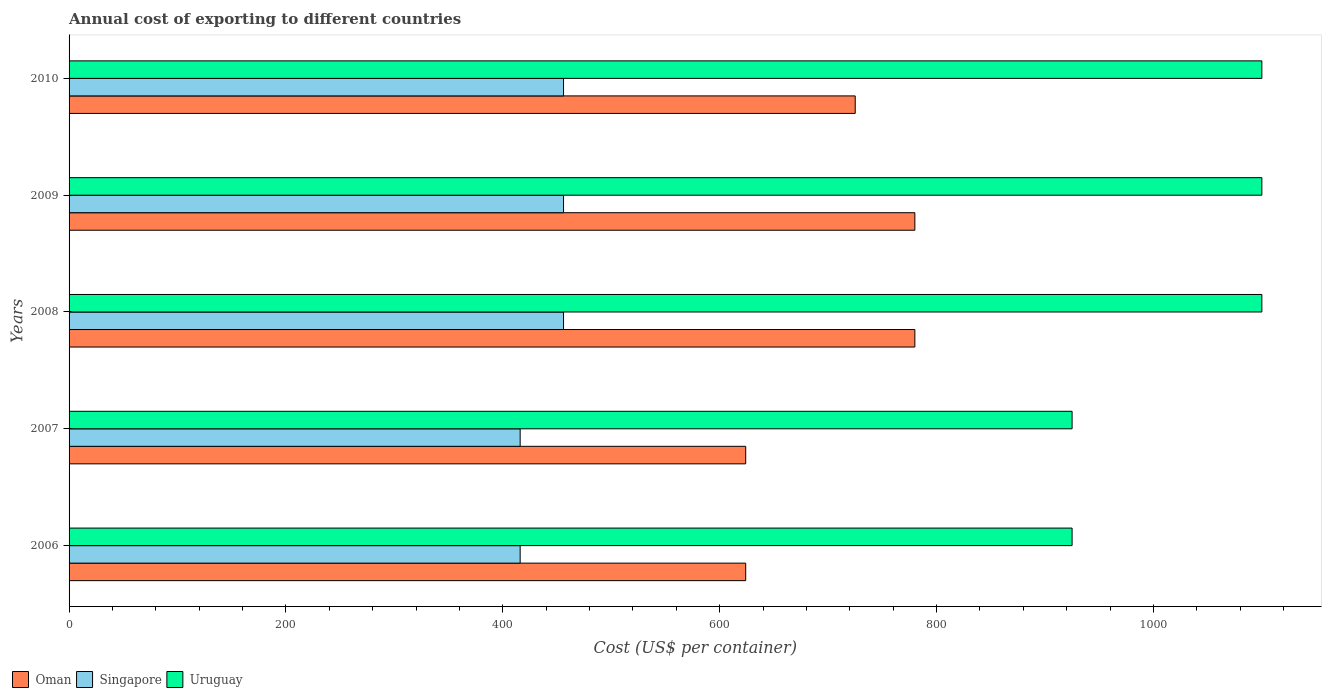How many groups of bars are there?
Your response must be concise. 5. Are the number of bars per tick equal to the number of legend labels?
Offer a very short reply. Yes. What is the total annual cost of exporting in Uruguay in 2007?
Your answer should be very brief. 925. Across all years, what is the maximum total annual cost of exporting in Uruguay?
Make the answer very short. 1100. Across all years, what is the minimum total annual cost of exporting in Singapore?
Offer a very short reply. 416. In which year was the total annual cost of exporting in Oman maximum?
Ensure brevity in your answer.  2008. In which year was the total annual cost of exporting in Singapore minimum?
Offer a terse response. 2006. What is the total total annual cost of exporting in Oman in the graph?
Ensure brevity in your answer.  3533. What is the difference between the total annual cost of exporting in Singapore in 2007 and that in 2008?
Make the answer very short. -40. What is the difference between the total annual cost of exporting in Oman in 2009 and the total annual cost of exporting in Singapore in 2007?
Provide a short and direct response. 364. What is the average total annual cost of exporting in Singapore per year?
Make the answer very short. 440. In the year 2009, what is the difference between the total annual cost of exporting in Uruguay and total annual cost of exporting in Singapore?
Keep it short and to the point. 644. In how many years, is the total annual cost of exporting in Oman greater than 440 US$?
Keep it short and to the point. 5. What is the difference between the highest and the lowest total annual cost of exporting in Oman?
Provide a succinct answer. 156. In how many years, is the total annual cost of exporting in Oman greater than the average total annual cost of exporting in Oman taken over all years?
Give a very brief answer. 3. Is the sum of the total annual cost of exporting in Oman in 2007 and 2010 greater than the maximum total annual cost of exporting in Singapore across all years?
Offer a very short reply. Yes. What does the 3rd bar from the top in 2010 represents?
Offer a very short reply. Oman. What does the 3rd bar from the bottom in 2006 represents?
Ensure brevity in your answer.  Uruguay. Are all the bars in the graph horizontal?
Provide a short and direct response. Yes. How many years are there in the graph?
Your answer should be compact. 5. Are the values on the major ticks of X-axis written in scientific E-notation?
Offer a terse response. No. Does the graph contain grids?
Give a very brief answer. No. How many legend labels are there?
Your response must be concise. 3. How are the legend labels stacked?
Offer a very short reply. Horizontal. What is the title of the graph?
Your answer should be very brief. Annual cost of exporting to different countries. What is the label or title of the X-axis?
Make the answer very short. Cost (US$ per container). What is the label or title of the Y-axis?
Give a very brief answer. Years. What is the Cost (US$ per container) of Oman in 2006?
Keep it short and to the point. 624. What is the Cost (US$ per container) of Singapore in 2006?
Your response must be concise. 416. What is the Cost (US$ per container) in Uruguay in 2006?
Keep it short and to the point. 925. What is the Cost (US$ per container) of Oman in 2007?
Keep it short and to the point. 624. What is the Cost (US$ per container) of Singapore in 2007?
Provide a succinct answer. 416. What is the Cost (US$ per container) in Uruguay in 2007?
Provide a short and direct response. 925. What is the Cost (US$ per container) in Oman in 2008?
Your answer should be compact. 780. What is the Cost (US$ per container) of Singapore in 2008?
Provide a short and direct response. 456. What is the Cost (US$ per container) of Uruguay in 2008?
Offer a terse response. 1100. What is the Cost (US$ per container) of Oman in 2009?
Offer a terse response. 780. What is the Cost (US$ per container) of Singapore in 2009?
Give a very brief answer. 456. What is the Cost (US$ per container) in Uruguay in 2009?
Ensure brevity in your answer.  1100. What is the Cost (US$ per container) in Oman in 2010?
Offer a terse response. 725. What is the Cost (US$ per container) in Singapore in 2010?
Provide a short and direct response. 456. What is the Cost (US$ per container) in Uruguay in 2010?
Offer a very short reply. 1100. Across all years, what is the maximum Cost (US$ per container) in Oman?
Offer a terse response. 780. Across all years, what is the maximum Cost (US$ per container) in Singapore?
Offer a terse response. 456. Across all years, what is the maximum Cost (US$ per container) of Uruguay?
Offer a very short reply. 1100. Across all years, what is the minimum Cost (US$ per container) of Oman?
Give a very brief answer. 624. Across all years, what is the minimum Cost (US$ per container) in Singapore?
Your answer should be very brief. 416. Across all years, what is the minimum Cost (US$ per container) in Uruguay?
Make the answer very short. 925. What is the total Cost (US$ per container) of Oman in the graph?
Provide a short and direct response. 3533. What is the total Cost (US$ per container) in Singapore in the graph?
Your response must be concise. 2200. What is the total Cost (US$ per container) of Uruguay in the graph?
Give a very brief answer. 5150. What is the difference between the Cost (US$ per container) in Oman in 2006 and that in 2007?
Provide a succinct answer. 0. What is the difference between the Cost (US$ per container) in Uruguay in 2006 and that in 2007?
Give a very brief answer. 0. What is the difference between the Cost (US$ per container) in Oman in 2006 and that in 2008?
Your answer should be compact. -156. What is the difference between the Cost (US$ per container) of Uruguay in 2006 and that in 2008?
Give a very brief answer. -175. What is the difference between the Cost (US$ per container) in Oman in 2006 and that in 2009?
Ensure brevity in your answer.  -156. What is the difference between the Cost (US$ per container) of Uruguay in 2006 and that in 2009?
Your response must be concise. -175. What is the difference between the Cost (US$ per container) of Oman in 2006 and that in 2010?
Keep it short and to the point. -101. What is the difference between the Cost (US$ per container) of Singapore in 2006 and that in 2010?
Ensure brevity in your answer.  -40. What is the difference between the Cost (US$ per container) of Uruguay in 2006 and that in 2010?
Ensure brevity in your answer.  -175. What is the difference between the Cost (US$ per container) in Oman in 2007 and that in 2008?
Your answer should be very brief. -156. What is the difference between the Cost (US$ per container) of Singapore in 2007 and that in 2008?
Your response must be concise. -40. What is the difference between the Cost (US$ per container) in Uruguay in 2007 and that in 2008?
Your answer should be very brief. -175. What is the difference between the Cost (US$ per container) of Oman in 2007 and that in 2009?
Offer a very short reply. -156. What is the difference between the Cost (US$ per container) in Singapore in 2007 and that in 2009?
Your answer should be compact. -40. What is the difference between the Cost (US$ per container) of Uruguay in 2007 and that in 2009?
Provide a short and direct response. -175. What is the difference between the Cost (US$ per container) of Oman in 2007 and that in 2010?
Your answer should be very brief. -101. What is the difference between the Cost (US$ per container) in Uruguay in 2007 and that in 2010?
Your response must be concise. -175. What is the difference between the Cost (US$ per container) in Singapore in 2008 and that in 2009?
Give a very brief answer. 0. What is the difference between the Cost (US$ per container) of Uruguay in 2008 and that in 2009?
Provide a succinct answer. 0. What is the difference between the Cost (US$ per container) of Oman in 2008 and that in 2010?
Provide a short and direct response. 55. What is the difference between the Cost (US$ per container) of Singapore in 2008 and that in 2010?
Give a very brief answer. 0. What is the difference between the Cost (US$ per container) of Oman in 2009 and that in 2010?
Offer a terse response. 55. What is the difference between the Cost (US$ per container) of Uruguay in 2009 and that in 2010?
Your answer should be compact. 0. What is the difference between the Cost (US$ per container) in Oman in 2006 and the Cost (US$ per container) in Singapore in 2007?
Offer a terse response. 208. What is the difference between the Cost (US$ per container) in Oman in 2006 and the Cost (US$ per container) in Uruguay in 2007?
Your answer should be compact. -301. What is the difference between the Cost (US$ per container) in Singapore in 2006 and the Cost (US$ per container) in Uruguay in 2007?
Provide a short and direct response. -509. What is the difference between the Cost (US$ per container) in Oman in 2006 and the Cost (US$ per container) in Singapore in 2008?
Give a very brief answer. 168. What is the difference between the Cost (US$ per container) in Oman in 2006 and the Cost (US$ per container) in Uruguay in 2008?
Your response must be concise. -476. What is the difference between the Cost (US$ per container) of Singapore in 2006 and the Cost (US$ per container) of Uruguay in 2008?
Your response must be concise. -684. What is the difference between the Cost (US$ per container) in Oman in 2006 and the Cost (US$ per container) in Singapore in 2009?
Your answer should be compact. 168. What is the difference between the Cost (US$ per container) in Oman in 2006 and the Cost (US$ per container) in Uruguay in 2009?
Offer a terse response. -476. What is the difference between the Cost (US$ per container) of Singapore in 2006 and the Cost (US$ per container) of Uruguay in 2009?
Offer a very short reply. -684. What is the difference between the Cost (US$ per container) in Oman in 2006 and the Cost (US$ per container) in Singapore in 2010?
Your answer should be compact. 168. What is the difference between the Cost (US$ per container) in Oman in 2006 and the Cost (US$ per container) in Uruguay in 2010?
Provide a short and direct response. -476. What is the difference between the Cost (US$ per container) of Singapore in 2006 and the Cost (US$ per container) of Uruguay in 2010?
Your answer should be compact. -684. What is the difference between the Cost (US$ per container) in Oman in 2007 and the Cost (US$ per container) in Singapore in 2008?
Ensure brevity in your answer.  168. What is the difference between the Cost (US$ per container) of Oman in 2007 and the Cost (US$ per container) of Uruguay in 2008?
Your answer should be compact. -476. What is the difference between the Cost (US$ per container) of Singapore in 2007 and the Cost (US$ per container) of Uruguay in 2008?
Provide a succinct answer. -684. What is the difference between the Cost (US$ per container) of Oman in 2007 and the Cost (US$ per container) of Singapore in 2009?
Provide a short and direct response. 168. What is the difference between the Cost (US$ per container) of Oman in 2007 and the Cost (US$ per container) of Uruguay in 2009?
Provide a succinct answer. -476. What is the difference between the Cost (US$ per container) of Singapore in 2007 and the Cost (US$ per container) of Uruguay in 2009?
Provide a short and direct response. -684. What is the difference between the Cost (US$ per container) of Oman in 2007 and the Cost (US$ per container) of Singapore in 2010?
Your answer should be very brief. 168. What is the difference between the Cost (US$ per container) in Oman in 2007 and the Cost (US$ per container) in Uruguay in 2010?
Your answer should be very brief. -476. What is the difference between the Cost (US$ per container) in Singapore in 2007 and the Cost (US$ per container) in Uruguay in 2010?
Offer a terse response. -684. What is the difference between the Cost (US$ per container) in Oman in 2008 and the Cost (US$ per container) in Singapore in 2009?
Ensure brevity in your answer.  324. What is the difference between the Cost (US$ per container) of Oman in 2008 and the Cost (US$ per container) of Uruguay in 2009?
Your answer should be compact. -320. What is the difference between the Cost (US$ per container) in Singapore in 2008 and the Cost (US$ per container) in Uruguay in 2009?
Give a very brief answer. -644. What is the difference between the Cost (US$ per container) of Oman in 2008 and the Cost (US$ per container) of Singapore in 2010?
Your response must be concise. 324. What is the difference between the Cost (US$ per container) in Oman in 2008 and the Cost (US$ per container) in Uruguay in 2010?
Make the answer very short. -320. What is the difference between the Cost (US$ per container) in Singapore in 2008 and the Cost (US$ per container) in Uruguay in 2010?
Your answer should be compact. -644. What is the difference between the Cost (US$ per container) of Oman in 2009 and the Cost (US$ per container) of Singapore in 2010?
Keep it short and to the point. 324. What is the difference between the Cost (US$ per container) of Oman in 2009 and the Cost (US$ per container) of Uruguay in 2010?
Your answer should be very brief. -320. What is the difference between the Cost (US$ per container) in Singapore in 2009 and the Cost (US$ per container) in Uruguay in 2010?
Keep it short and to the point. -644. What is the average Cost (US$ per container) of Oman per year?
Give a very brief answer. 706.6. What is the average Cost (US$ per container) in Singapore per year?
Your response must be concise. 440. What is the average Cost (US$ per container) of Uruguay per year?
Make the answer very short. 1030. In the year 2006, what is the difference between the Cost (US$ per container) of Oman and Cost (US$ per container) of Singapore?
Your answer should be very brief. 208. In the year 2006, what is the difference between the Cost (US$ per container) in Oman and Cost (US$ per container) in Uruguay?
Ensure brevity in your answer.  -301. In the year 2006, what is the difference between the Cost (US$ per container) in Singapore and Cost (US$ per container) in Uruguay?
Provide a short and direct response. -509. In the year 2007, what is the difference between the Cost (US$ per container) in Oman and Cost (US$ per container) in Singapore?
Your answer should be very brief. 208. In the year 2007, what is the difference between the Cost (US$ per container) of Oman and Cost (US$ per container) of Uruguay?
Provide a succinct answer. -301. In the year 2007, what is the difference between the Cost (US$ per container) in Singapore and Cost (US$ per container) in Uruguay?
Offer a terse response. -509. In the year 2008, what is the difference between the Cost (US$ per container) in Oman and Cost (US$ per container) in Singapore?
Ensure brevity in your answer.  324. In the year 2008, what is the difference between the Cost (US$ per container) of Oman and Cost (US$ per container) of Uruguay?
Keep it short and to the point. -320. In the year 2008, what is the difference between the Cost (US$ per container) in Singapore and Cost (US$ per container) in Uruguay?
Your response must be concise. -644. In the year 2009, what is the difference between the Cost (US$ per container) in Oman and Cost (US$ per container) in Singapore?
Your answer should be compact. 324. In the year 2009, what is the difference between the Cost (US$ per container) in Oman and Cost (US$ per container) in Uruguay?
Offer a very short reply. -320. In the year 2009, what is the difference between the Cost (US$ per container) in Singapore and Cost (US$ per container) in Uruguay?
Make the answer very short. -644. In the year 2010, what is the difference between the Cost (US$ per container) in Oman and Cost (US$ per container) in Singapore?
Offer a very short reply. 269. In the year 2010, what is the difference between the Cost (US$ per container) of Oman and Cost (US$ per container) of Uruguay?
Provide a short and direct response. -375. In the year 2010, what is the difference between the Cost (US$ per container) of Singapore and Cost (US$ per container) of Uruguay?
Ensure brevity in your answer.  -644. What is the ratio of the Cost (US$ per container) in Uruguay in 2006 to that in 2007?
Offer a very short reply. 1. What is the ratio of the Cost (US$ per container) in Singapore in 2006 to that in 2008?
Your answer should be compact. 0.91. What is the ratio of the Cost (US$ per container) of Uruguay in 2006 to that in 2008?
Offer a very short reply. 0.84. What is the ratio of the Cost (US$ per container) in Singapore in 2006 to that in 2009?
Provide a succinct answer. 0.91. What is the ratio of the Cost (US$ per container) in Uruguay in 2006 to that in 2009?
Ensure brevity in your answer.  0.84. What is the ratio of the Cost (US$ per container) of Oman in 2006 to that in 2010?
Provide a short and direct response. 0.86. What is the ratio of the Cost (US$ per container) in Singapore in 2006 to that in 2010?
Your answer should be compact. 0.91. What is the ratio of the Cost (US$ per container) in Uruguay in 2006 to that in 2010?
Your answer should be compact. 0.84. What is the ratio of the Cost (US$ per container) in Singapore in 2007 to that in 2008?
Give a very brief answer. 0.91. What is the ratio of the Cost (US$ per container) in Uruguay in 2007 to that in 2008?
Ensure brevity in your answer.  0.84. What is the ratio of the Cost (US$ per container) in Oman in 2007 to that in 2009?
Keep it short and to the point. 0.8. What is the ratio of the Cost (US$ per container) in Singapore in 2007 to that in 2009?
Provide a succinct answer. 0.91. What is the ratio of the Cost (US$ per container) in Uruguay in 2007 to that in 2009?
Ensure brevity in your answer.  0.84. What is the ratio of the Cost (US$ per container) of Oman in 2007 to that in 2010?
Provide a short and direct response. 0.86. What is the ratio of the Cost (US$ per container) in Singapore in 2007 to that in 2010?
Your answer should be very brief. 0.91. What is the ratio of the Cost (US$ per container) in Uruguay in 2007 to that in 2010?
Provide a succinct answer. 0.84. What is the ratio of the Cost (US$ per container) of Oman in 2008 to that in 2009?
Offer a very short reply. 1. What is the ratio of the Cost (US$ per container) of Oman in 2008 to that in 2010?
Your answer should be compact. 1.08. What is the ratio of the Cost (US$ per container) in Singapore in 2008 to that in 2010?
Offer a very short reply. 1. What is the ratio of the Cost (US$ per container) in Uruguay in 2008 to that in 2010?
Ensure brevity in your answer.  1. What is the ratio of the Cost (US$ per container) of Oman in 2009 to that in 2010?
Offer a terse response. 1.08. What is the ratio of the Cost (US$ per container) of Uruguay in 2009 to that in 2010?
Provide a short and direct response. 1. What is the difference between the highest and the second highest Cost (US$ per container) in Oman?
Provide a short and direct response. 0. What is the difference between the highest and the lowest Cost (US$ per container) in Oman?
Make the answer very short. 156. What is the difference between the highest and the lowest Cost (US$ per container) in Singapore?
Your answer should be very brief. 40. What is the difference between the highest and the lowest Cost (US$ per container) of Uruguay?
Your answer should be very brief. 175. 